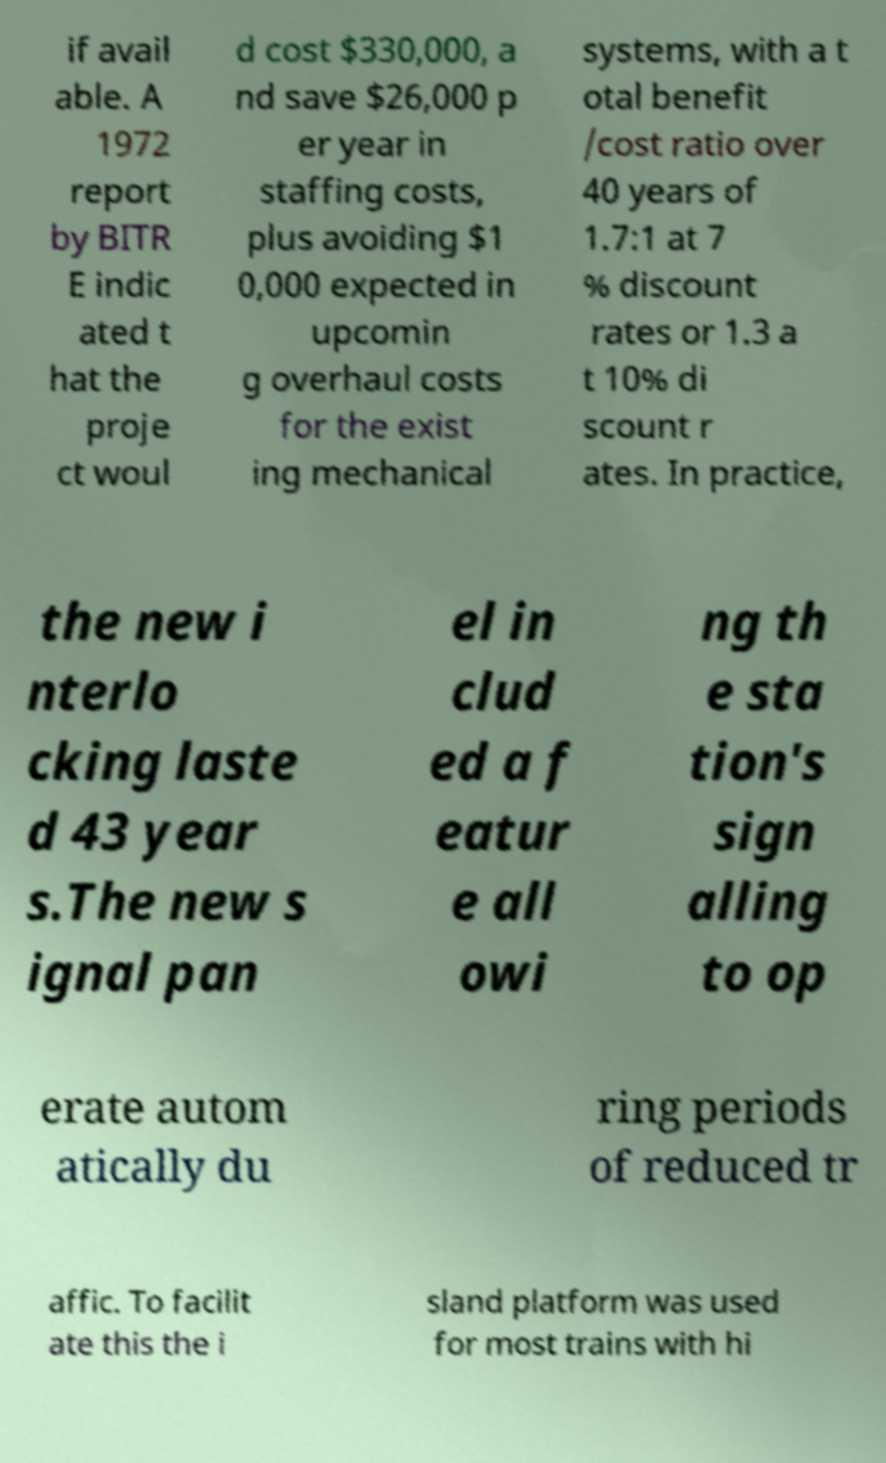There's text embedded in this image that I need extracted. Can you transcribe it verbatim? if avail able. A 1972 report by BITR E indic ated t hat the proje ct woul d cost $330,000, a nd save $26,000 p er year in staffing costs, plus avoiding $1 0,000 expected in upcomin g overhaul costs for the exist ing mechanical systems, with a t otal benefit /cost ratio over 40 years of 1.7:1 at 7 % discount rates or 1.3 a t 10% di scount r ates. In practice, the new i nterlo cking laste d 43 year s.The new s ignal pan el in clud ed a f eatur e all owi ng th e sta tion's sign alling to op erate autom atically du ring periods of reduced tr affic. To facilit ate this the i sland platform was used for most trains with hi 